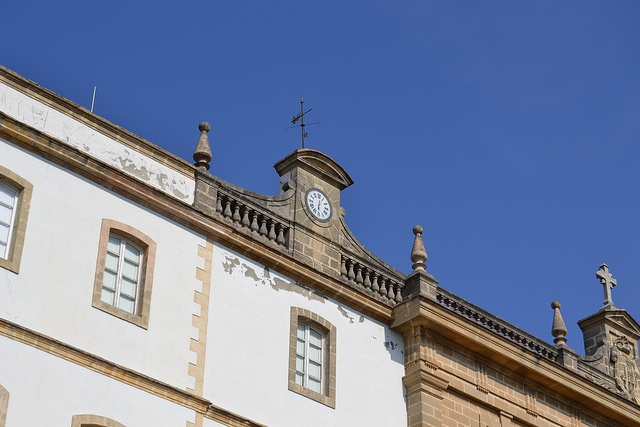Describe the objects in this image and their specific colors. I can see a clock in blue, lightgray, gray, and darkgray tones in this image. 